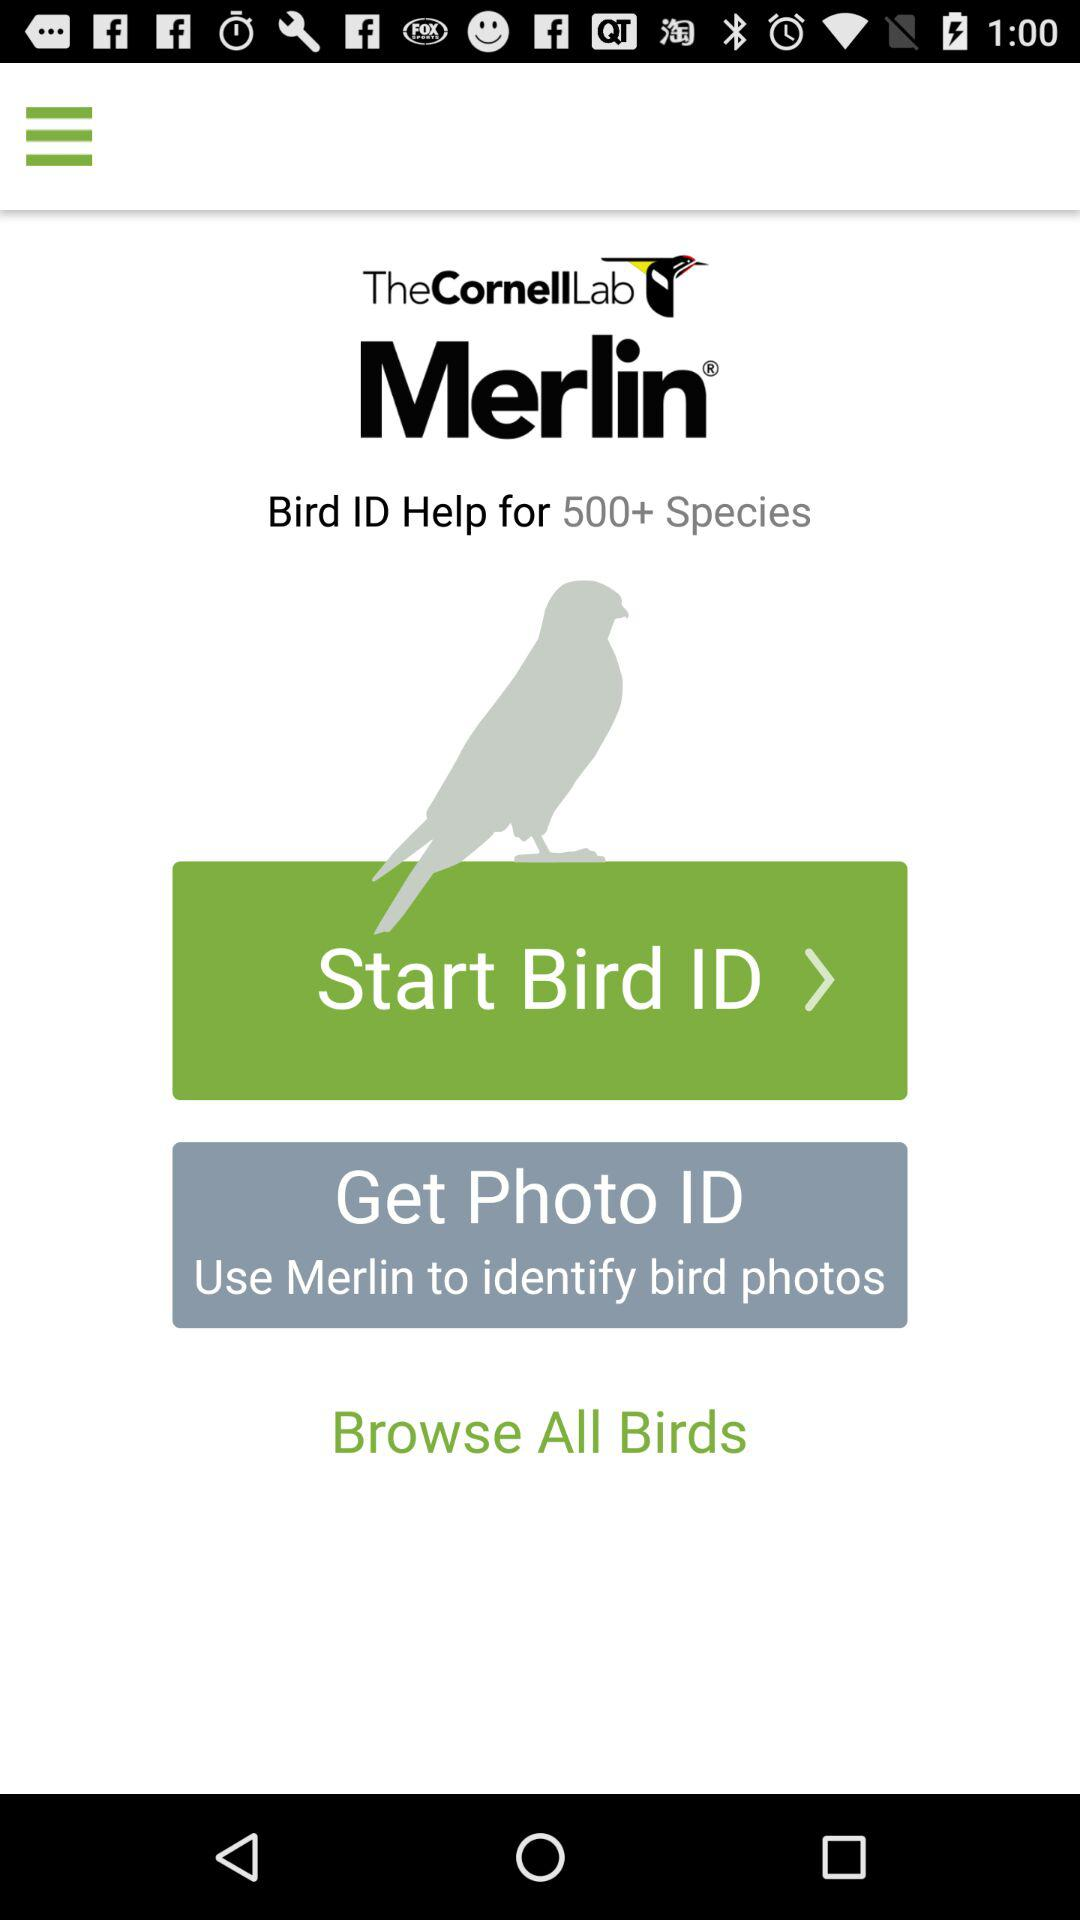How can bird photos be identified? Bird photos can be identified by using "Merlin". 